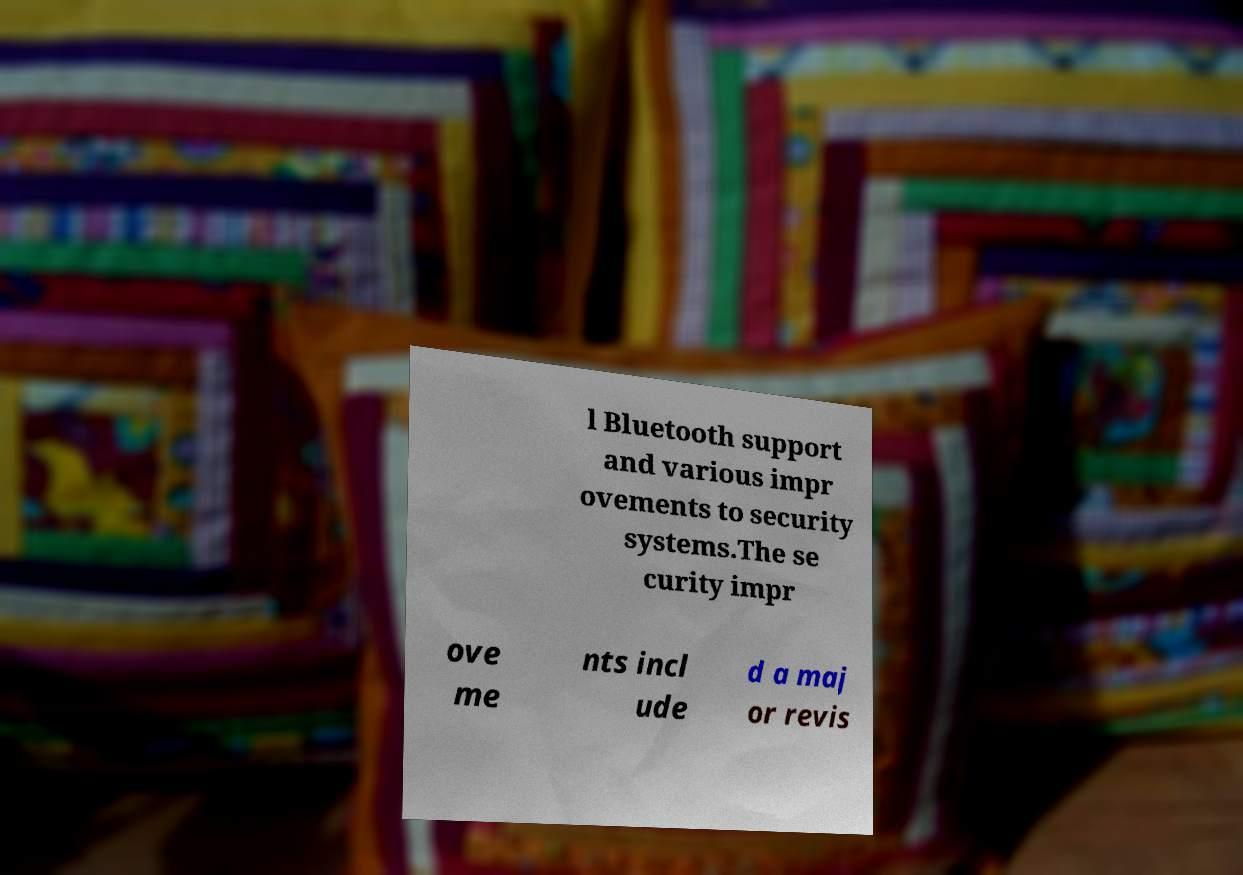For documentation purposes, I need the text within this image transcribed. Could you provide that? l Bluetooth support and various impr ovements to security systems.The se curity impr ove me nts incl ude d a maj or revis 